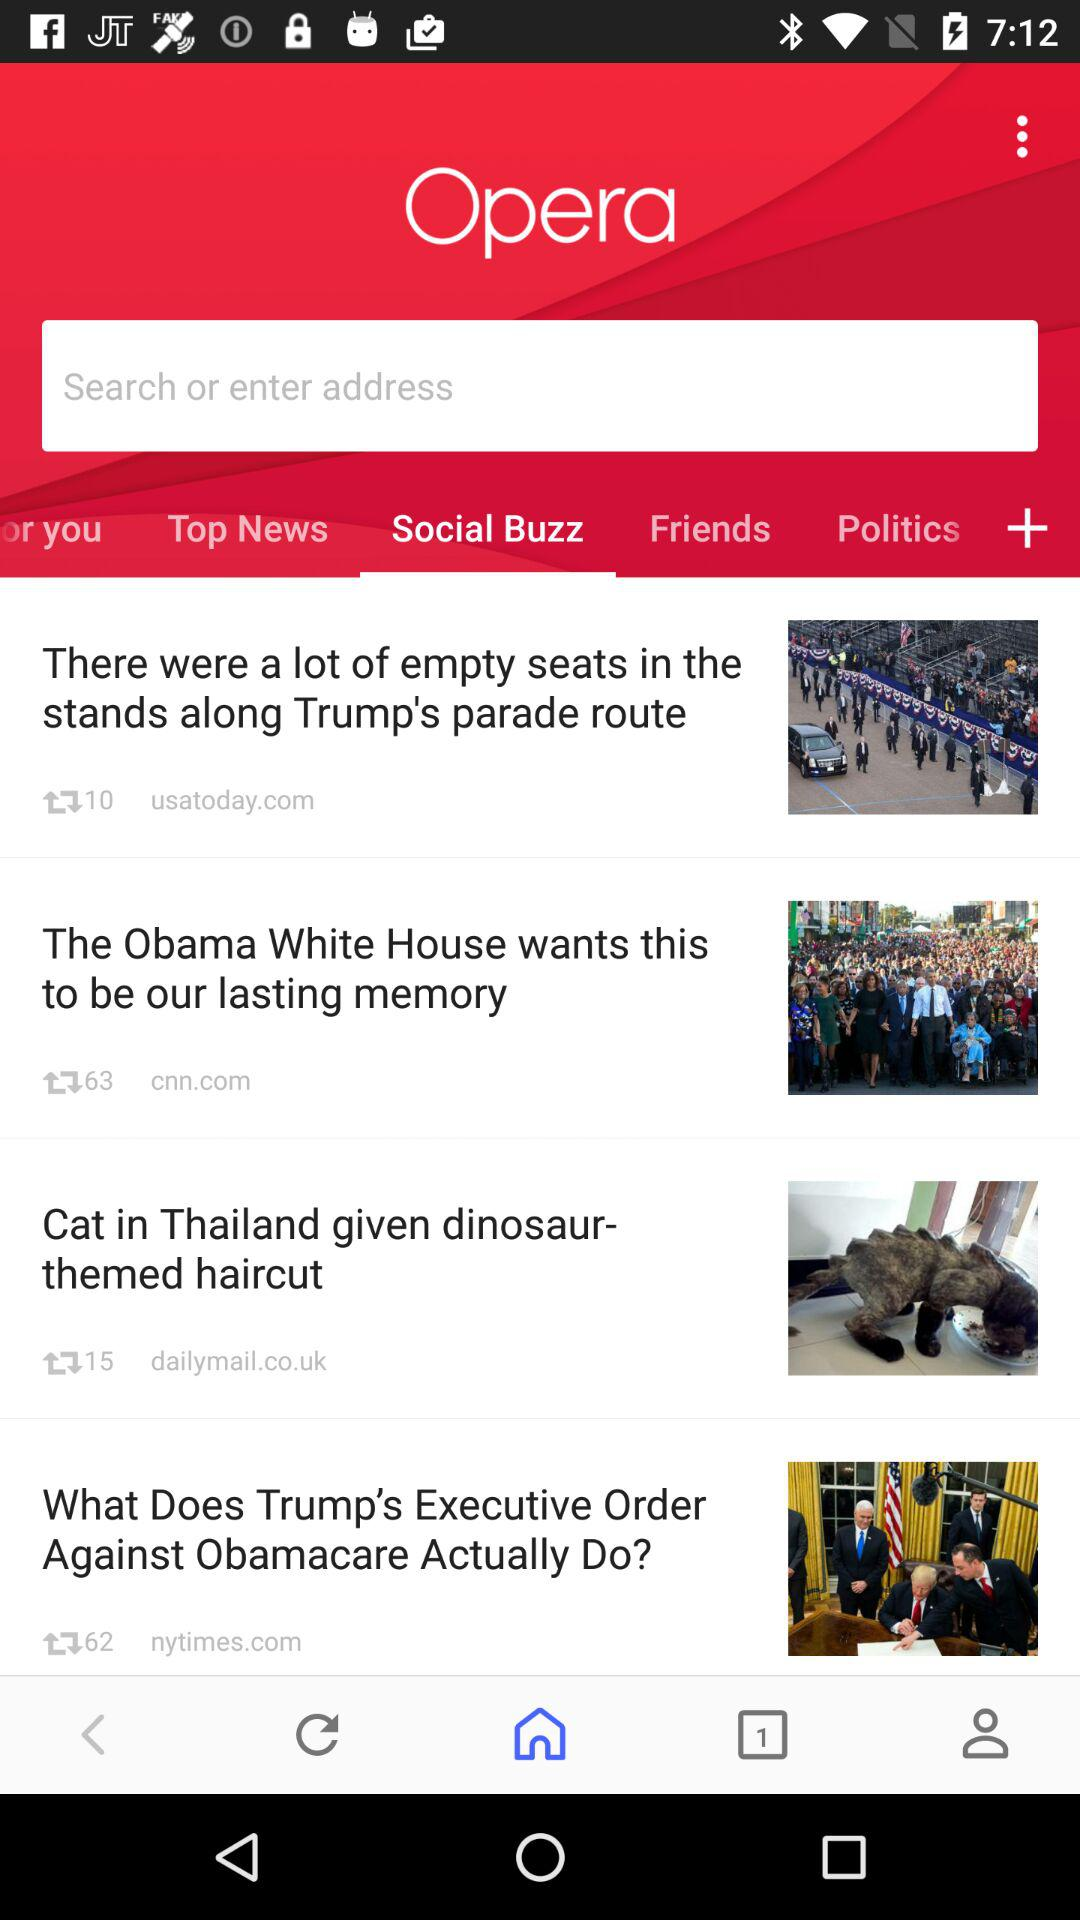How many headlines are there?
Answer the question using a single word or phrase. 4 